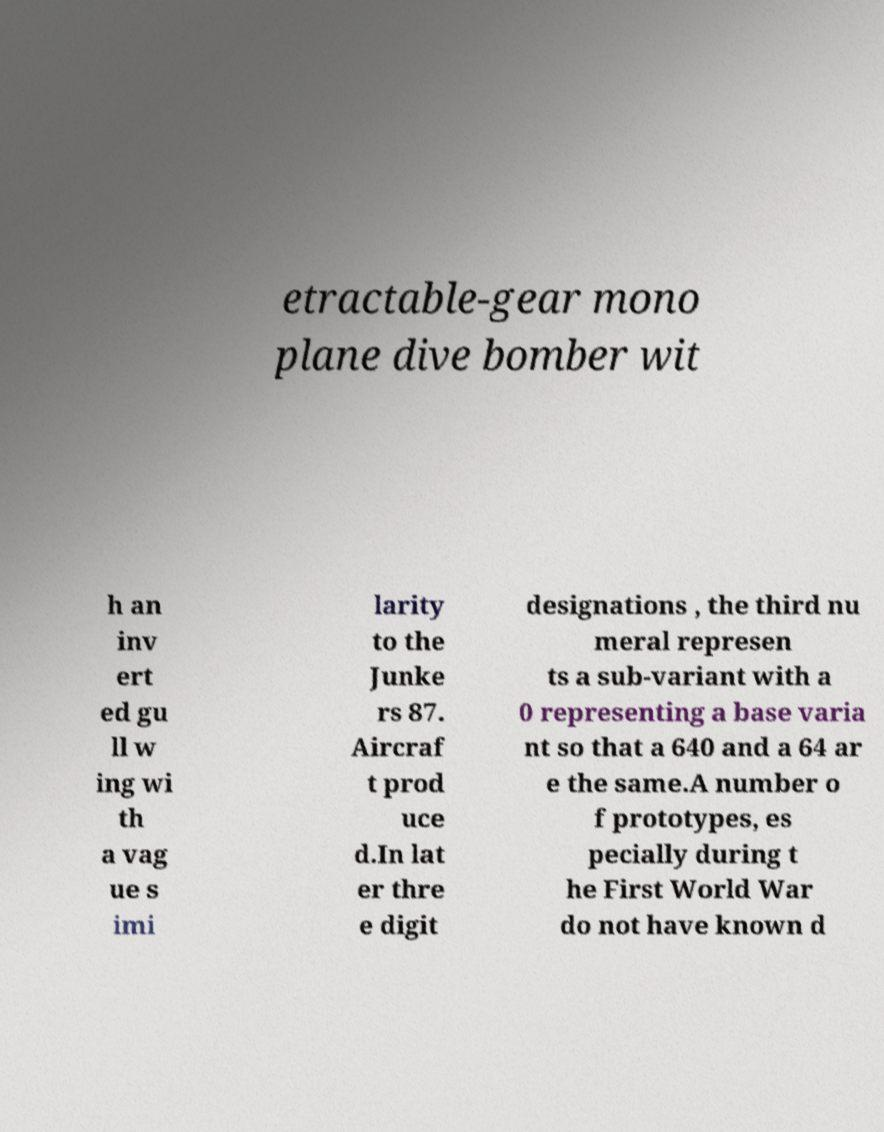I need the written content from this picture converted into text. Can you do that? etractable-gear mono plane dive bomber wit h an inv ert ed gu ll w ing wi th a vag ue s imi larity to the Junke rs 87. Aircraf t prod uce d.In lat er thre e digit designations , the third nu meral represen ts a sub-variant with a 0 representing a base varia nt so that a 640 and a 64 ar e the same.A number o f prototypes, es pecially during t he First World War do not have known d 